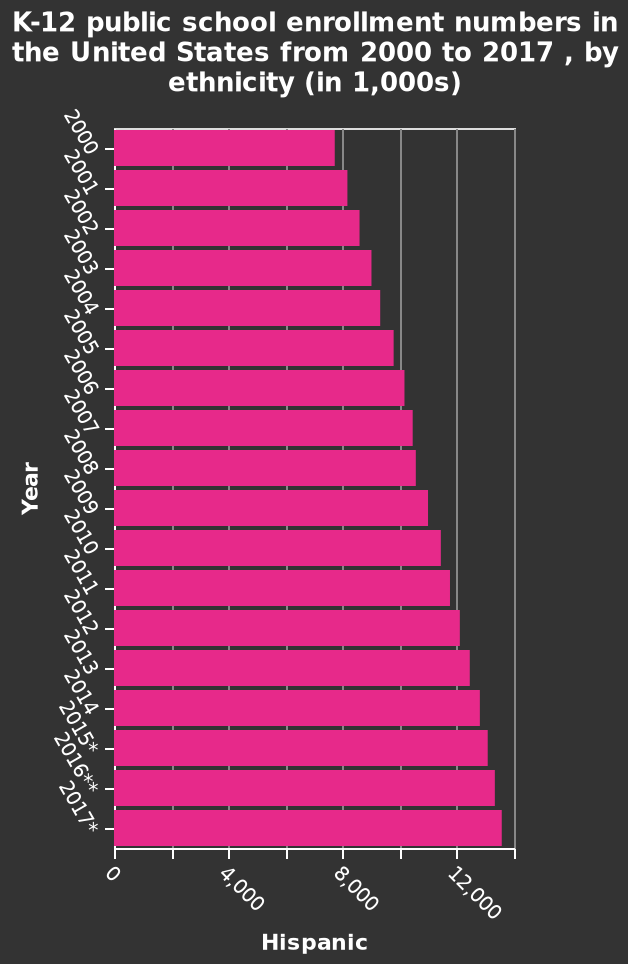<image>
Describe the following image in detail K-12 public school enrollment numbers in the United States from 2000 to 2017 , by ethnicity (in 1,000s) is a bar graph. The x-axis plots Hispanic while the y-axis shows Year. Offer a thorough analysis of the image. The number of Hispanic children being enrolled in k-12 public schools has trended upwards since 2000 from just under 8000 to around 15000 in 2017. How much has the enrollment of Hispanic children in k-12 public schools increased from 2000 to 2017? The enrollment of Hispanic children in k-12 public schools has increased by approximately 7000 students from 2000 to 2017. How has the enrollment of Hispanic children in k-12 public schools changed since 2000?  The enrollment of Hispanic children in k-12 public schools has trended upwards since 2000. please summary the statistics and relations of the chart From 2000 to 2017 the level of Hispanic students gradually increased from 8,000 to approximately 15,000. 